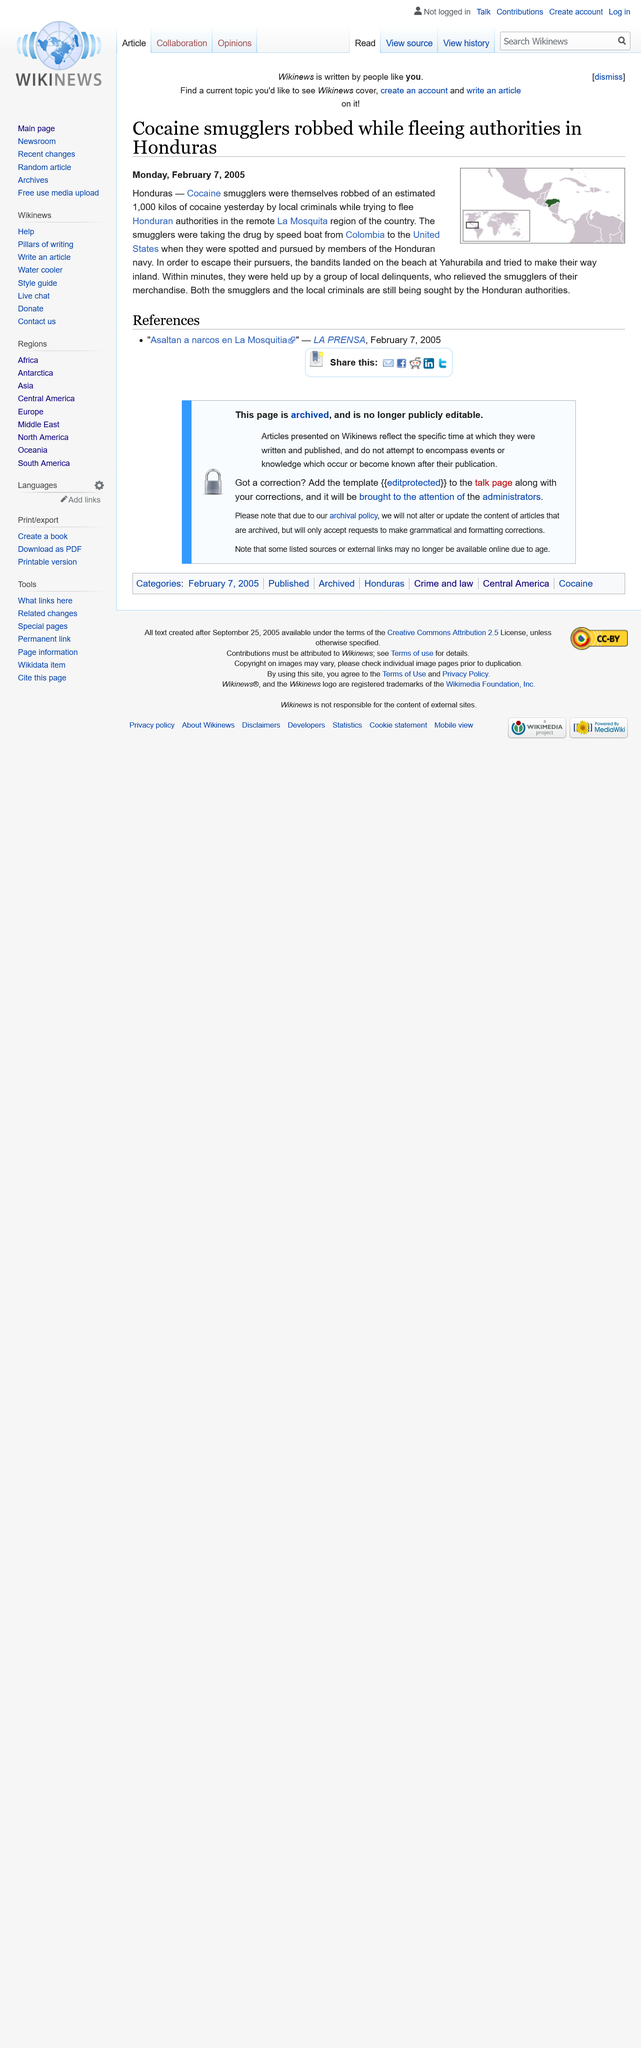Outline some significant characteristics in this image. Cocaine smugglers who were attempting to evade authorities in Honduras were victims of a robbery. The smugglers were transporting the drug by speed boat. This article was published in the month of February. 